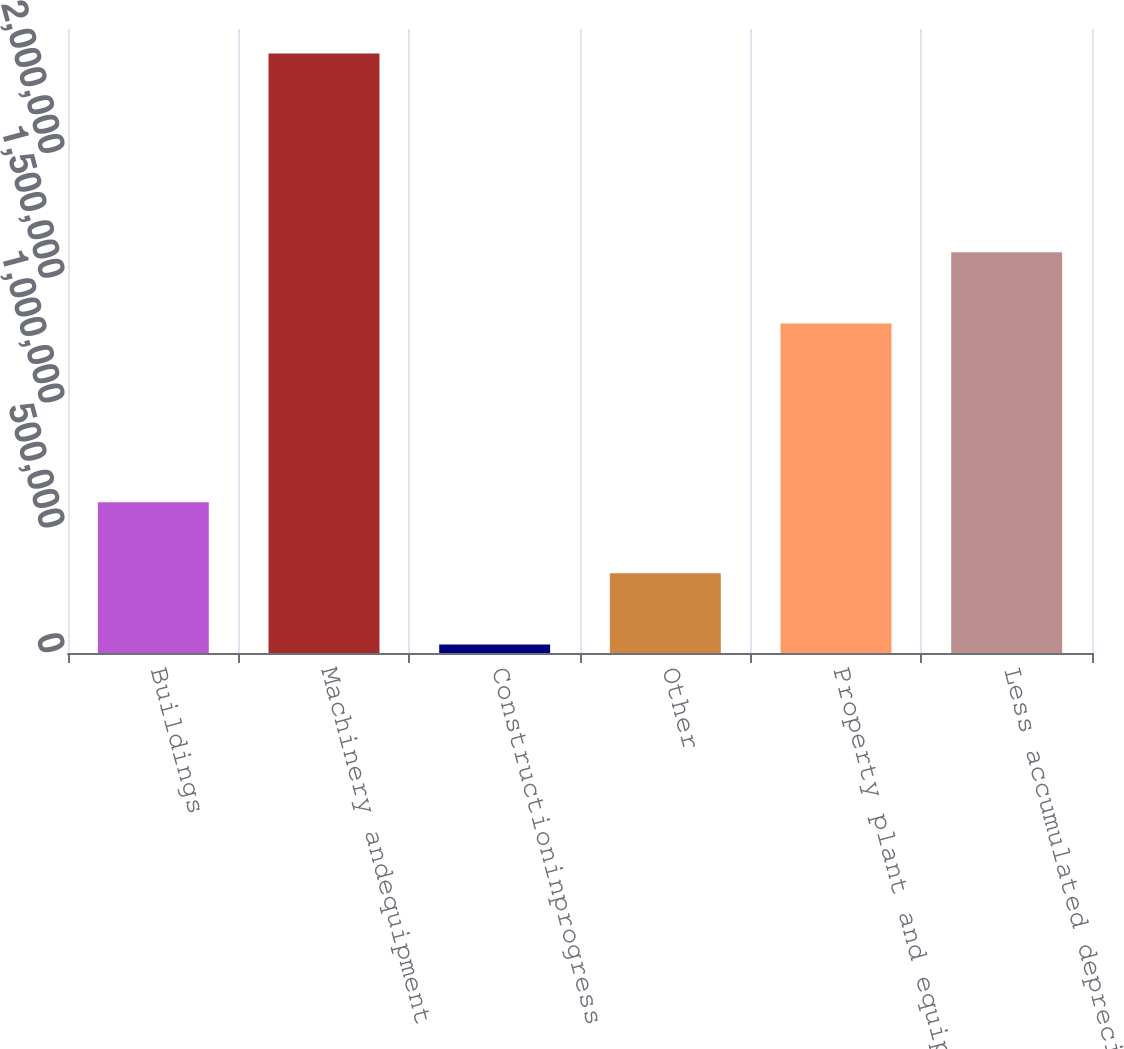<chart> <loc_0><loc_0><loc_500><loc_500><bar_chart><fcel>Buildings<fcel>Machinery andequipment<fcel>Constructioninprogress<fcel>Other<fcel>Property plant and equipment<fcel>Less accumulated depreciation<nl><fcel>604218<fcel>2.4014e+06<fcel>34054<fcel>319136<fcel>1.32051e+06<fcel>1.60559e+06<nl></chart> 